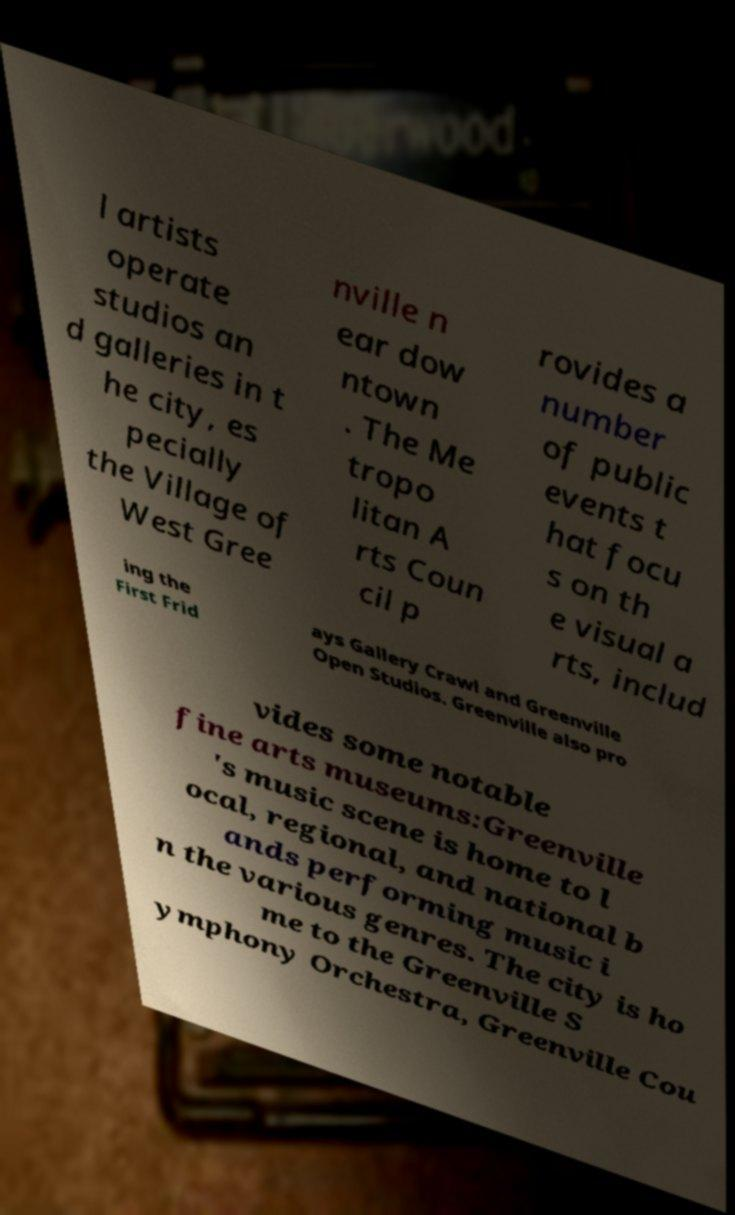Please read and relay the text visible in this image. What does it say? l artists operate studios an d galleries in t he city, es pecially the Village of West Gree nville n ear dow ntown . The Me tropo litan A rts Coun cil p rovides a number of public events t hat focu s on th e visual a rts, includ ing the First Frid ays Gallery Crawl and Greenville Open Studios. Greenville also pro vides some notable fine arts museums:Greenville 's music scene is home to l ocal, regional, and national b ands performing music i n the various genres. The city is ho me to the Greenville S ymphony Orchestra, Greenville Cou 